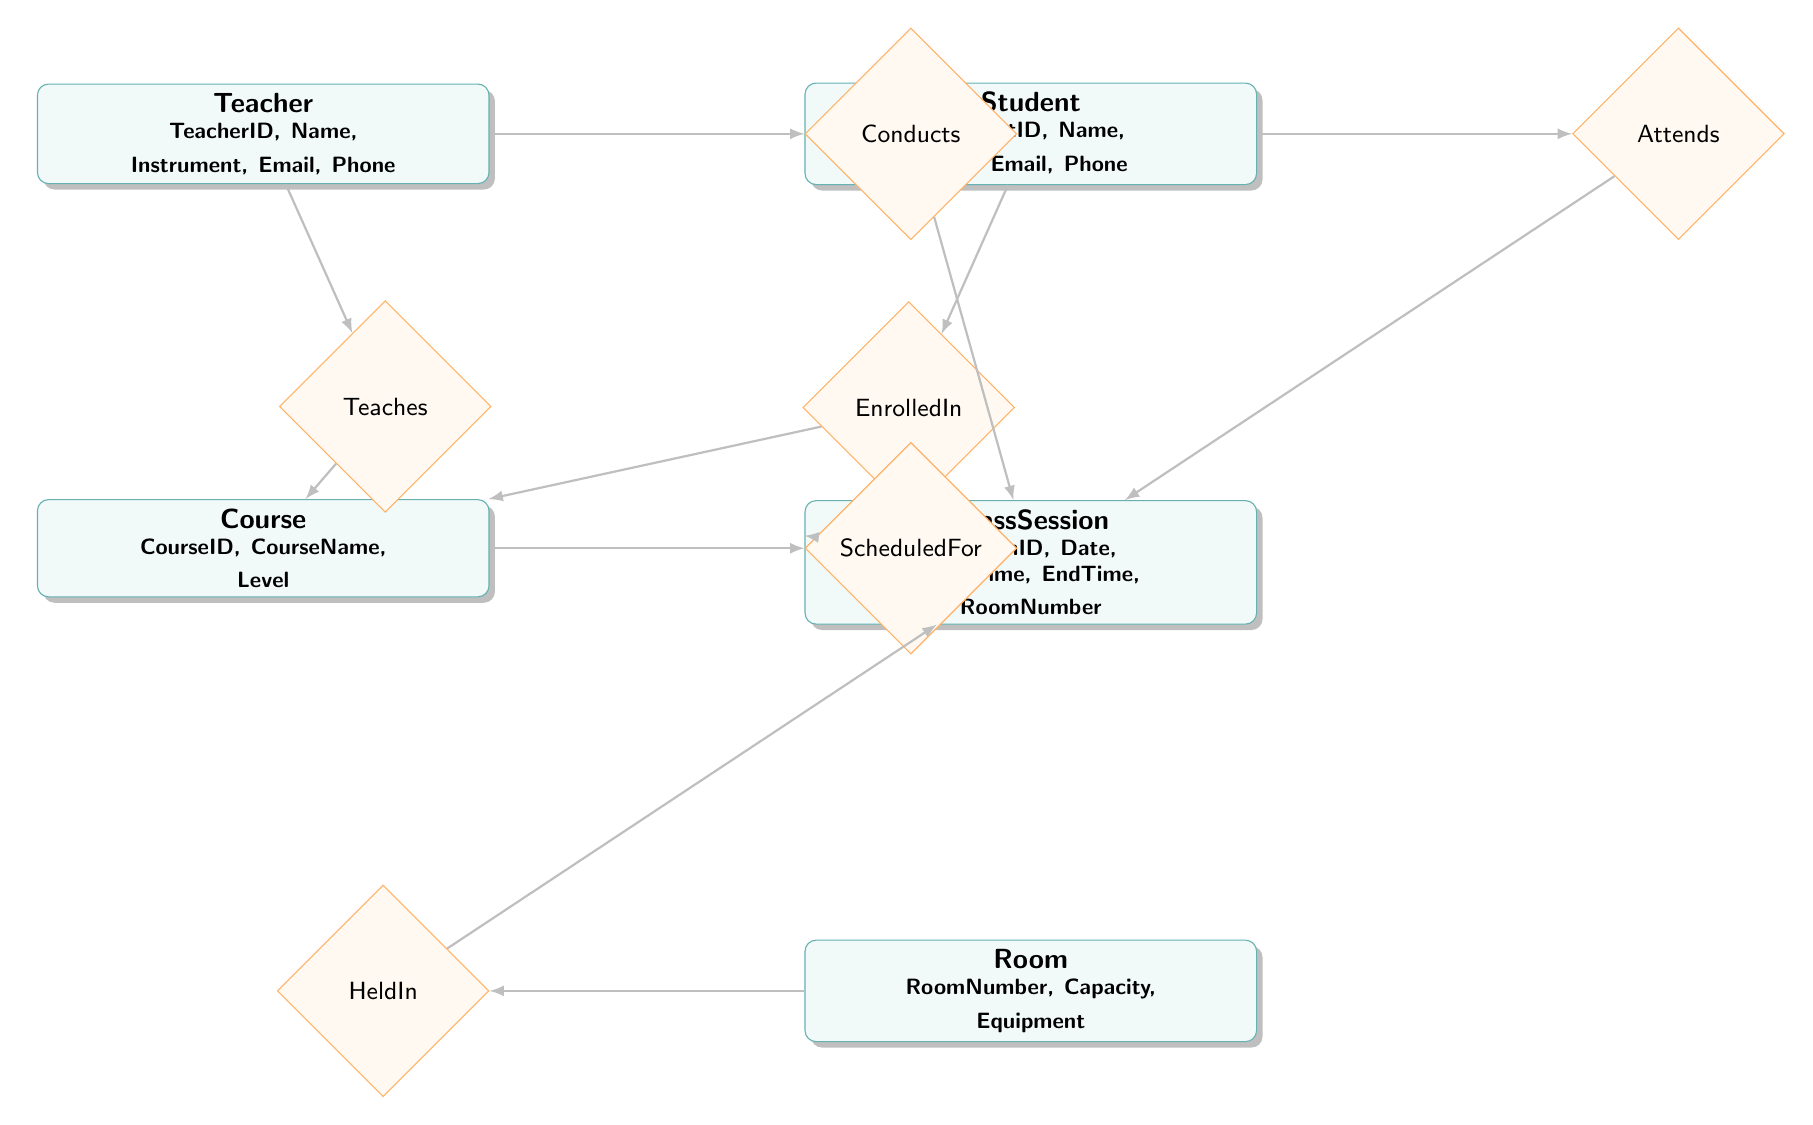What entities are included in the diagram? The diagram includes five entities: Teacher, Student, Course, ClassSession, and Room.
Answer: Teacher, Student, Course, ClassSession, Room How many relationships are depicted in the diagram? The diagram shows six relationships connecting the entities: Teaches, EnrolledIn, ScheduledFor, HeldIn, Conducts, and Attends.
Answer: Six What is the relationship between Teacher and Course? The diagram indicates the relationship between Teacher and Course is "Teaches." This means that teachers instruct their respective courses.
Answer: Teaches Which entity is related to ClassSession through the HeldIn relationship? The Room entity is related to ClassSession through the HeldIn relationship, indicating which room a class session takes place in.
Answer: Room What is the main purpose of the EnrolledIn relationship? The EnrolledIn relationship connects the Student entity to the Course entity, indicating which courses students are enrolled in.
Answer: To indicate enrollment How does a ClassSession relate to both Room and Course? The ClassSession entity is connected to the Room entity through the HeldIn relationship and to the Course entity through the ScheduledFor relationship. This shows that a class session is scheduled for a specific course in a specific room.
Answer: Through ScheduledFor and HeldIn Which entity has the attribute "Capacity"? The Room entity has the attribute "Capacity," which defines the number of individuals that the room can accommodate.
Answer: Room How many attributes does the Teacher entity have? The Teacher entity includes five attributes: TeacherID, Name, Instrument, Email, and Phone. Therefore, it has five attributes.
Answer: Five What does the Conducts relationship indicate in the context of the diagram? The Conducts relationship connects the Teacher entity to the ClassSession entity, signifying that a teacher conducts or leads the class session.
Answer: Teacher conducts ClassSession 